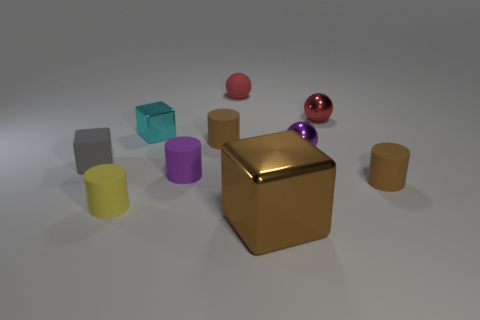Subtract all brown metallic blocks. How many blocks are left? 2 Subtract all yellow cylinders. How many cylinders are left? 3 Add 7 small red spheres. How many small red spheres are left? 9 Add 3 big cyan matte cylinders. How many big cyan matte cylinders exist? 3 Subtract 1 cyan blocks. How many objects are left? 9 Subtract all cubes. How many objects are left? 7 Subtract 1 balls. How many balls are left? 2 Subtract all blue balls. Subtract all red cubes. How many balls are left? 3 Subtract all gray balls. How many cyan cylinders are left? 0 Subtract all small metal things. Subtract all brown cylinders. How many objects are left? 5 